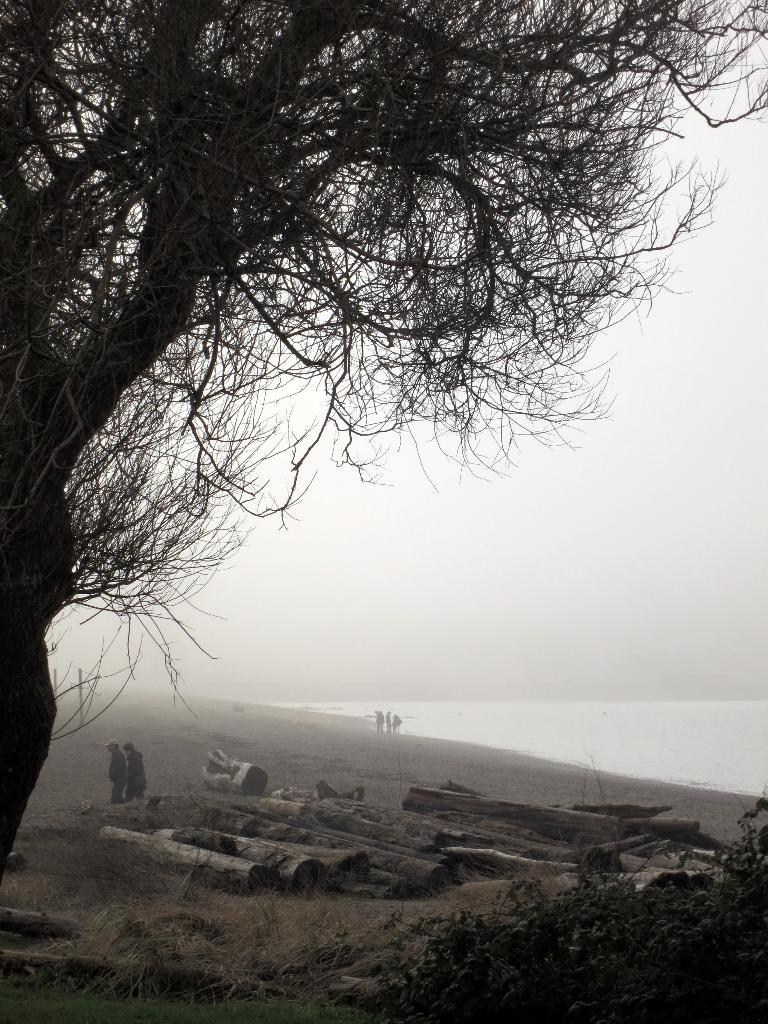What type of natural element can be seen in the image? There is a tree in the image. Are there any living beings present in the image? Yes, there are people in the image. What can be seen in the background of the image? There is water visible in the image. What type of snow can be seen falling in the image? There is no snow present in the image; it features a tree, people, and water. What experience can be gained from the image? The image itself does not provide an experience, but it may evoke feelings or memories related to nature, water, or people. 